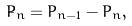Convert formula to latex. <formula><loc_0><loc_0><loc_500><loc_500>\dot { P } _ { n } = P _ { n - 1 } - P _ { n } ,</formula> 